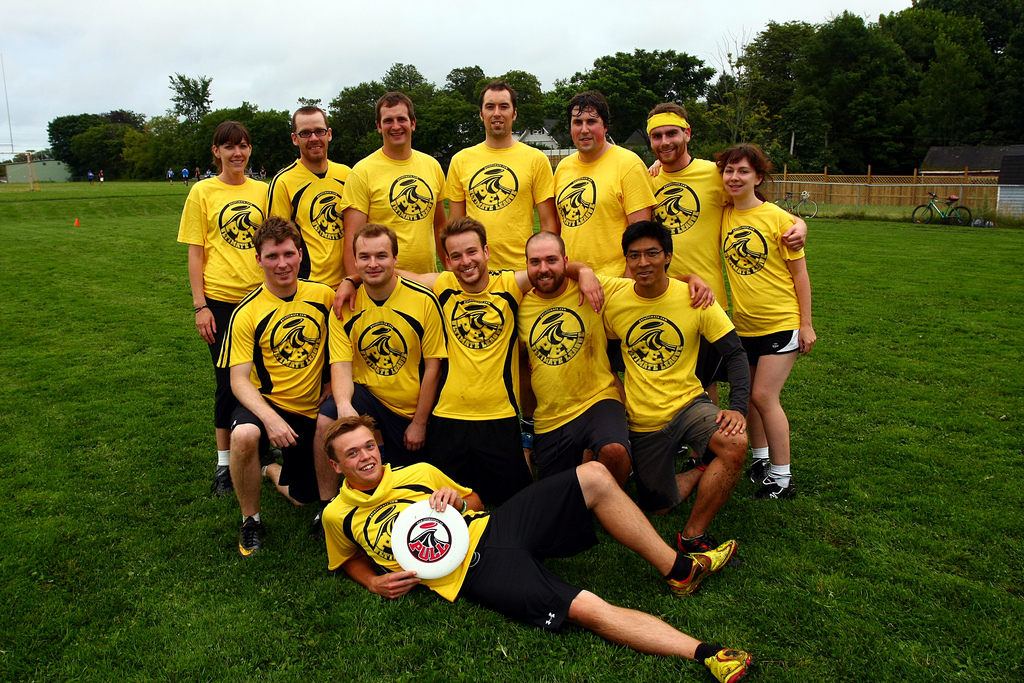Can you tell me more about the team dynamics? From the image, it's clear this group has a strong sense of camaraderie. Their matching uniforms signify unity, and their varying poses suggest a comfortable and relaxed team spirit. Their smiling faces indicate they enjoy each other's company and likely share a bond beyond just playing sports together. 